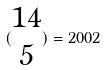Convert formula to latex. <formula><loc_0><loc_0><loc_500><loc_500>( \begin{matrix} 1 4 \\ 5 \end{matrix} ) = 2 0 0 2</formula> 